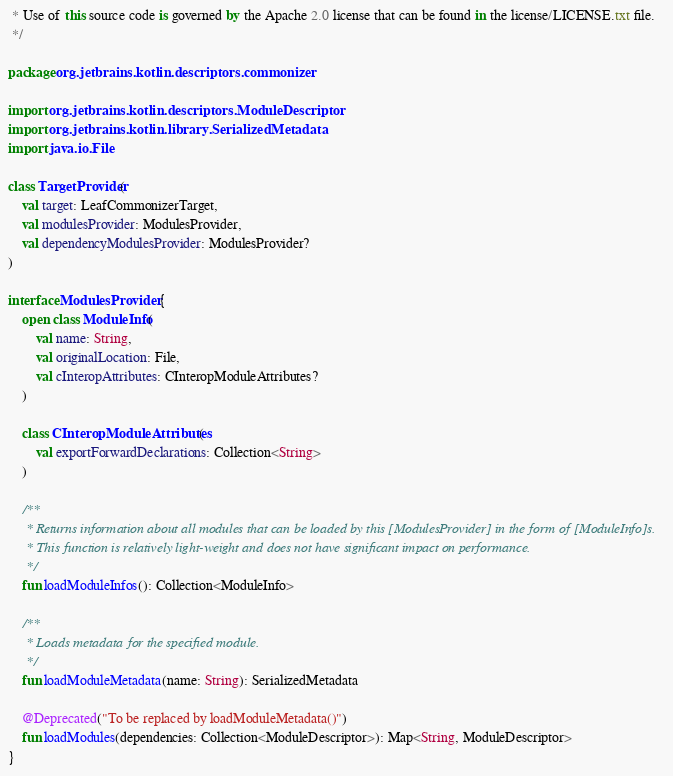<code> <loc_0><loc_0><loc_500><loc_500><_Kotlin_> * Use of this source code is governed by the Apache 2.0 license that can be found in the license/LICENSE.txt file.
 */

package org.jetbrains.kotlin.descriptors.commonizer

import org.jetbrains.kotlin.descriptors.ModuleDescriptor
import org.jetbrains.kotlin.library.SerializedMetadata
import java.io.File

class TargetProvider(
    val target: LeafCommonizerTarget,
    val modulesProvider: ModulesProvider,
    val dependencyModulesProvider: ModulesProvider?
)

interface ModulesProvider {
    open class ModuleInfo(
        val name: String,
        val originalLocation: File,
        val cInteropAttributes: CInteropModuleAttributes?
    )

    class CInteropModuleAttributes(
        val exportForwardDeclarations: Collection<String>
    )

    /**
     * Returns information about all modules that can be loaded by this [ModulesProvider] in the form of [ModuleInfo]s.
     * This function is relatively light-weight and does not have significant impact on performance.
     */
    fun loadModuleInfos(): Collection<ModuleInfo>

    /**
     * Loads metadata for the specified module.
     */
    fun loadModuleMetadata(name: String): SerializedMetadata

    @Deprecated("To be replaced by loadModuleMetadata()")
    fun loadModules(dependencies: Collection<ModuleDescriptor>): Map<String, ModuleDescriptor>
}
</code> 